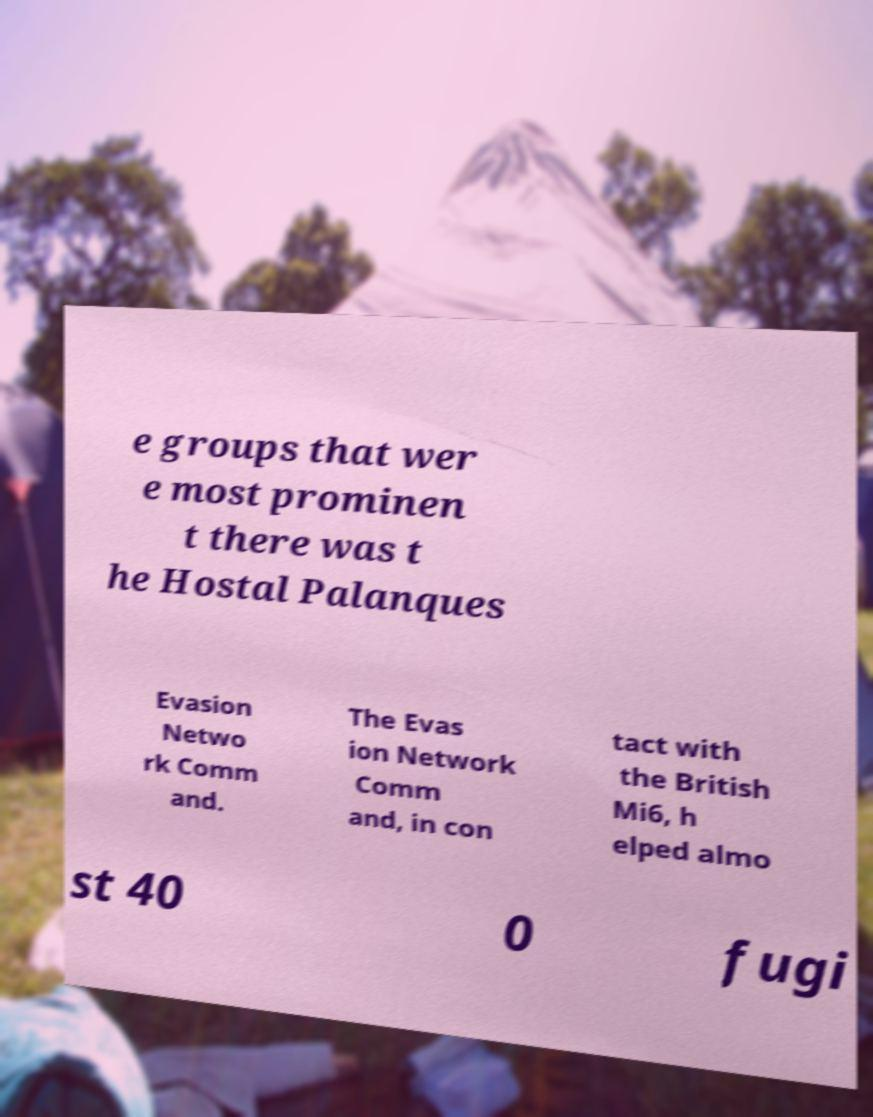Could you extract and type out the text from this image? e groups that wer e most prominen t there was t he Hostal Palanques Evasion Netwo rk Comm and. The Evas ion Network Comm and, in con tact with the British Mi6, h elped almo st 40 0 fugi 